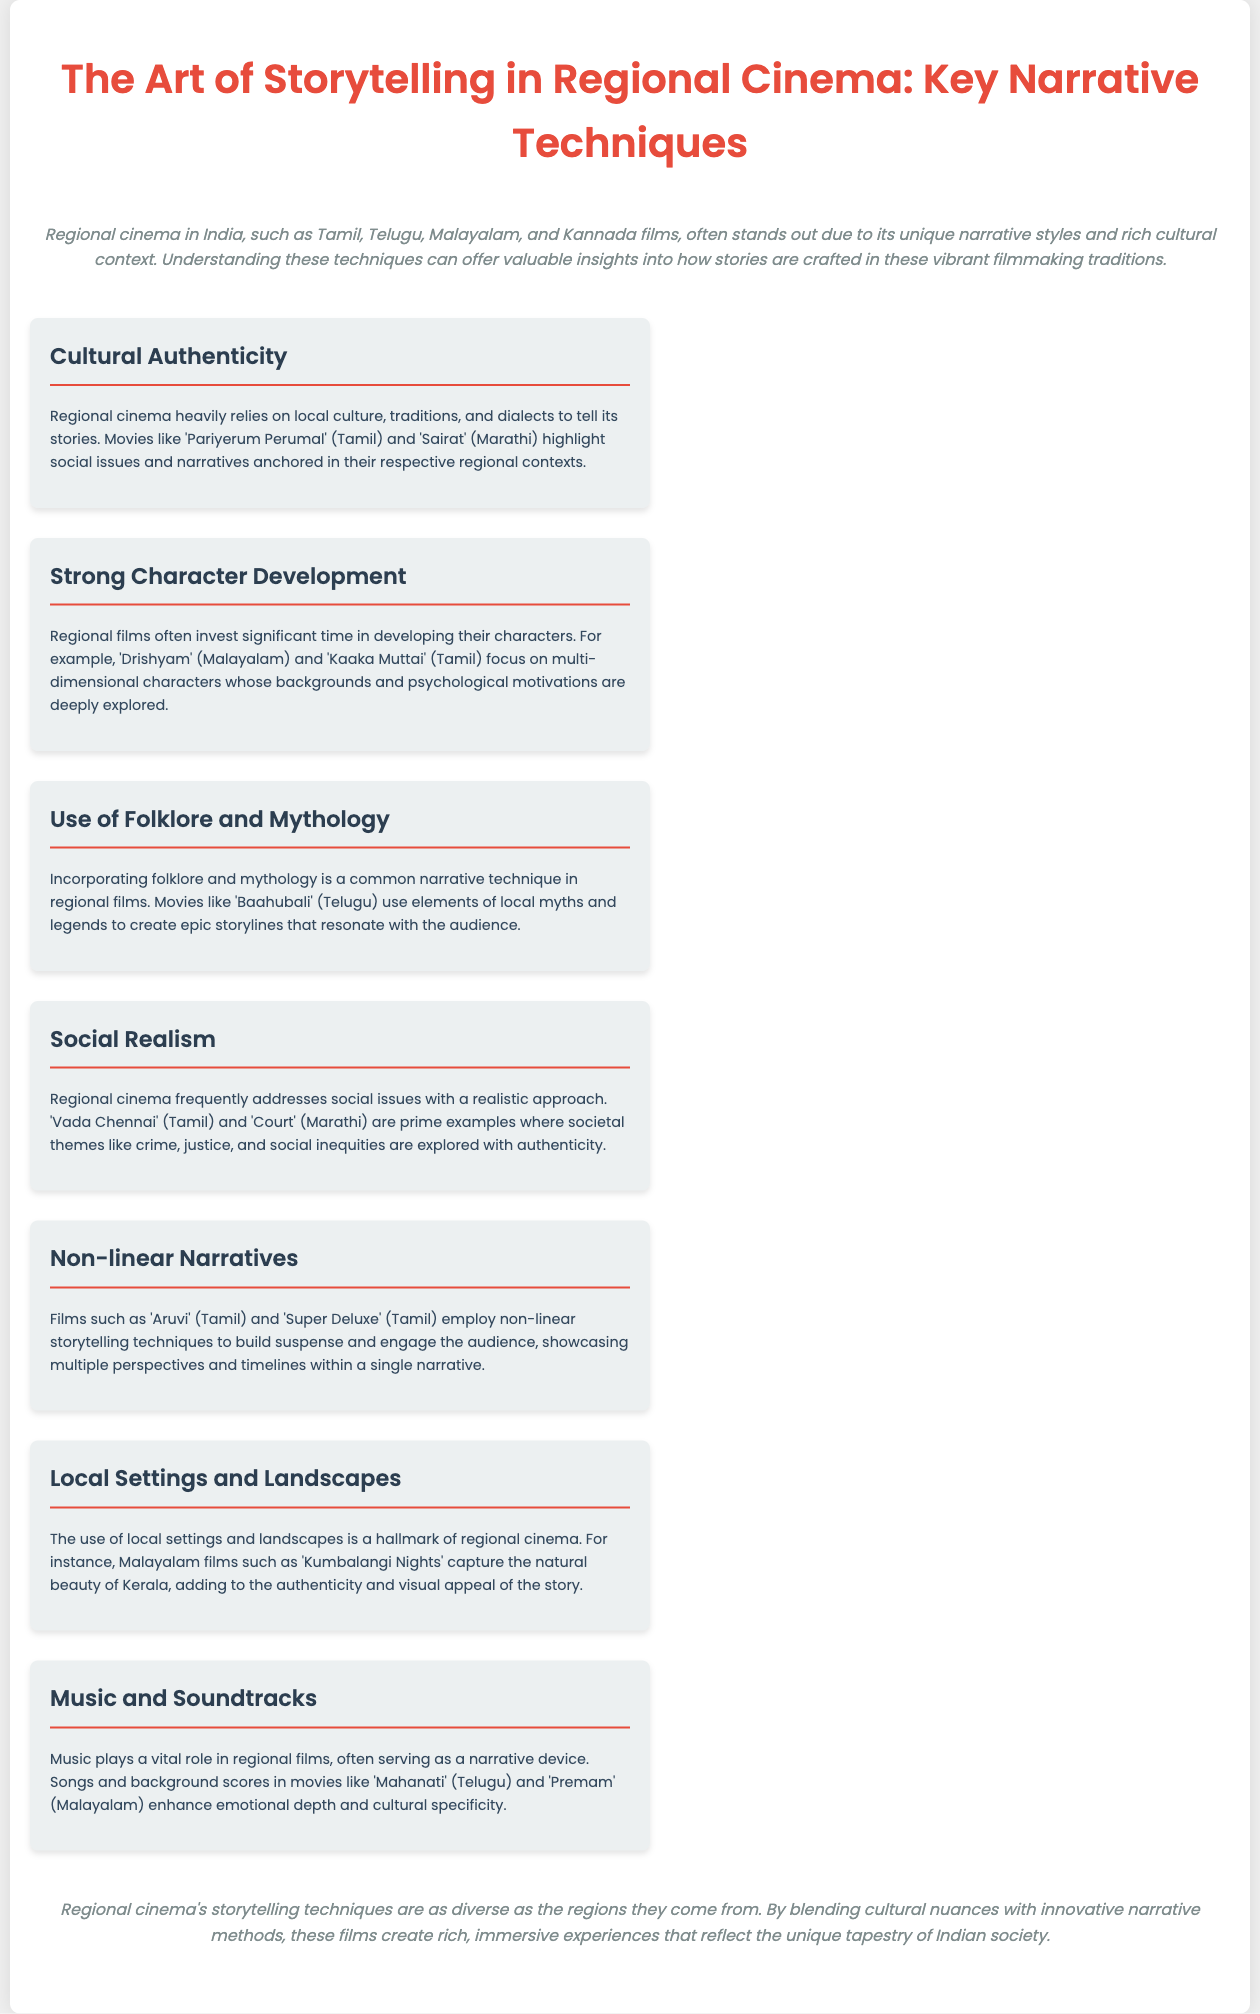What is the title of the infographic? The title is presented prominently at the beginning of the document, indicating the main subject of the content.
Answer: The Art of Storytelling in Regional Cinema: Key Narrative Techniques Which regional film is mentioned as an example of cultural authenticity? The document lists specific films as examples under various narrative techniques, highlighting 'Pariyerum Perumal' for cultural authenticity.
Answer: Pariyerum Perumal What narrative technique involves the exploration of multi-dimensional characters? The section discusses character development and highlights films that showcase significant character depth, indicating strong character development.
Answer: Strong Character Development Which film is noted for its use of mythology? A specific example is given in the document under the section discussing the incorporation of folklore and mythology.
Answer: Baahubali What is a common theme addressed in regional cinema as per the document? The document mentions social issues being explored through a realistic approach, highlighting themes prevalent in regional films.
Answer: Social Realism Which type of narrative does 'Aruvi' utilize? The document discusses various narrative techniques, including non-linear storytelling, specifically citing 'Aruvi' as an example.
Answer: Non-linear Narratives What is the impact of music in regional cinema? The infographic details how music serves as a narrative device, enhancing emotional depth within the films.
Answer: Vital role How does the document classify regional cinema storytelling techniques? It discusses that the techniques are diverse and reflect the unique tapestry of Indian society, leading to a specific classification.
Answer: As diverse as the regions What does the introduction state about regional cinema in India? The introduction highlights the uniqueness of regional cinema in India due to its narrative styles and cultural context.
Answer: Unique narrative styles and rich cultural context 